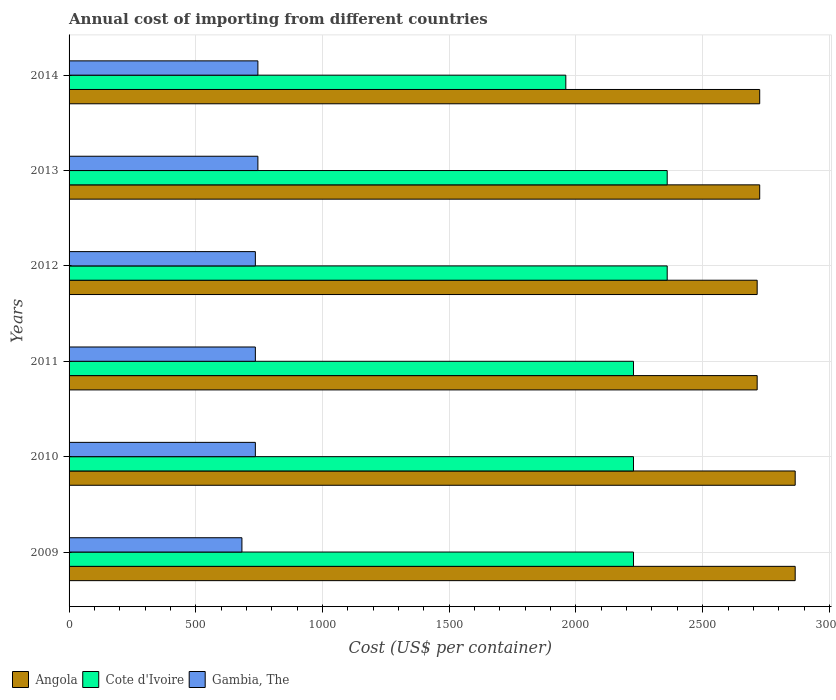How many groups of bars are there?
Offer a very short reply. 6. Are the number of bars on each tick of the Y-axis equal?
Keep it short and to the point. Yes. How many bars are there on the 1st tick from the top?
Your answer should be very brief. 3. How many bars are there on the 1st tick from the bottom?
Make the answer very short. 3. What is the label of the 3rd group of bars from the top?
Your response must be concise. 2012. In how many cases, is the number of bars for a given year not equal to the number of legend labels?
Provide a short and direct response. 0. What is the total annual cost of importing in Gambia, The in 2014?
Make the answer very short. 745. Across all years, what is the maximum total annual cost of importing in Gambia, The?
Keep it short and to the point. 745. Across all years, what is the minimum total annual cost of importing in Angola?
Your answer should be very brief. 2715. In which year was the total annual cost of importing in Cote d'Ivoire maximum?
Ensure brevity in your answer.  2012. What is the total total annual cost of importing in Gambia, The in the graph?
Ensure brevity in your answer.  4377. What is the difference between the total annual cost of importing in Gambia, The in 2012 and that in 2013?
Offer a very short reply. -10. What is the difference between the total annual cost of importing in Cote d'Ivoire in 2014 and the total annual cost of importing in Gambia, The in 2012?
Your response must be concise. 1225. What is the average total annual cost of importing in Angola per year?
Give a very brief answer. 2768.33. In the year 2009, what is the difference between the total annual cost of importing in Angola and total annual cost of importing in Gambia, The?
Ensure brevity in your answer.  2183. What is the ratio of the total annual cost of importing in Gambia, The in 2011 to that in 2014?
Provide a succinct answer. 0.99. Is the total annual cost of importing in Angola in 2012 less than that in 2013?
Make the answer very short. Yes. Is the difference between the total annual cost of importing in Angola in 2009 and 2010 greater than the difference between the total annual cost of importing in Gambia, The in 2009 and 2010?
Your answer should be very brief. Yes. What is the difference between the highest and the second highest total annual cost of importing in Angola?
Keep it short and to the point. 0. What is the difference between the highest and the lowest total annual cost of importing in Angola?
Make the answer very short. 150. In how many years, is the total annual cost of importing in Gambia, The greater than the average total annual cost of importing in Gambia, The taken over all years?
Ensure brevity in your answer.  5. What does the 3rd bar from the top in 2012 represents?
Give a very brief answer. Angola. What does the 1st bar from the bottom in 2010 represents?
Offer a very short reply. Angola. Is it the case that in every year, the sum of the total annual cost of importing in Gambia, The and total annual cost of importing in Cote d'Ivoire is greater than the total annual cost of importing in Angola?
Offer a terse response. No. Are all the bars in the graph horizontal?
Your response must be concise. Yes. What is the difference between two consecutive major ticks on the X-axis?
Make the answer very short. 500. Does the graph contain grids?
Your answer should be very brief. Yes. How many legend labels are there?
Provide a short and direct response. 3. What is the title of the graph?
Provide a succinct answer. Annual cost of importing from different countries. Does "Sweden" appear as one of the legend labels in the graph?
Keep it short and to the point. No. What is the label or title of the X-axis?
Offer a very short reply. Cost (US$ per container). What is the label or title of the Y-axis?
Give a very brief answer. Years. What is the Cost (US$ per container) of Angola in 2009?
Make the answer very short. 2865. What is the Cost (US$ per container) of Cote d'Ivoire in 2009?
Offer a terse response. 2227. What is the Cost (US$ per container) of Gambia, The in 2009?
Keep it short and to the point. 682. What is the Cost (US$ per container) of Angola in 2010?
Give a very brief answer. 2865. What is the Cost (US$ per container) of Cote d'Ivoire in 2010?
Offer a very short reply. 2227. What is the Cost (US$ per container) in Gambia, The in 2010?
Your response must be concise. 735. What is the Cost (US$ per container) of Angola in 2011?
Your answer should be compact. 2715. What is the Cost (US$ per container) in Cote d'Ivoire in 2011?
Provide a short and direct response. 2227. What is the Cost (US$ per container) in Gambia, The in 2011?
Make the answer very short. 735. What is the Cost (US$ per container) of Angola in 2012?
Your answer should be very brief. 2715. What is the Cost (US$ per container) of Cote d'Ivoire in 2012?
Your answer should be very brief. 2360. What is the Cost (US$ per container) in Gambia, The in 2012?
Your response must be concise. 735. What is the Cost (US$ per container) in Angola in 2013?
Provide a succinct answer. 2725. What is the Cost (US$ per container) of Cote d'Ivoire in 2013?
Offer a very short reply. 2360. What is the Cost (US$ per container) of Gambia, The in 2013?
Make the answer very short. 745. What is the Cost (US$ per container) in Angola in 2014?
Ensure brevity in your answer.  2725. What is the Cost (US$ per container) of Cote d'Ivoire in 2014?
Your response must be concise. 1960. What is the Cost (US$ per container) in Gambia, The in 2014?
Provide a short and direct response. 745. Across all years, what is the maximum Cost (US$ per container) in Angola?
Your response must be concise. 2865. Across all years, what is the maximum Cost (US$ per container) of Cote d'Ivoire?
Your answer should be compact. 2360. Across all years, what is the maximum Cost (US$ per container) in Gambia, The?
Give a very brief answer. 745. Across all years, what is the minimum Cost (US$ per container) in Angola?
Offer a terse response. 2715. Across all years, what is the minimum Cost (US$ per container) of Cote d'Ivoire?
Offer a very short reply. 1960. Across all years, what is the minimum Cost (US$ per container) in Gambia, The?
Offer a very short reply. 682. What is the total Cost (US$ per container) of Angola in the graph?
Provide a short and direct response. 1.66e+04. What is the total Cost (US$ per container) of Cote d'Ivoire in the graph?
Provide a short and direct response. 1.34e+04. What is the total Cost (US$ per container) of Gambia, The in the graph?
Your answer should be compact. 4377. What is the difference between the Cost (US$ per container) in Angola in 2009 and that in 2010?
Make the answer very short. 0. What is the difference between the Cost (US$ per container) in Gambia, The in 2009 and that in 2010?
Keep it short and to the point. -53. What is the difference between the Cost (US$ per container) in Angola in 2009 and that in 2011?
Offer a terse response. 150. What is the difference between the Cost (US$ per container) in Gambia, The in 2009 and that in 2011?
Provide a succinct answer. -53. What is the difference between the Cost (US$ per container) of Angola in 2009 and that in 2012?
Give a very brief answer. 150. What is the difference between the Cost (US$ per container) in Cote d'Ivoire in 2009 and that in 2012?
Your answer should be very brief. -133. What is the difference between the Cost (US$ per container) in Gambia, The in 2009 and that in 2012?
Offer a terse response. -53. What is the difference between the Cost (US$ per container) of Angola in 2009 and that in 2013?
Your answer should be very brief. 140. What is the difference between the Cost (US$ per container) in Cote d'Ivoire in 2009 and that in 2013?
Provide a short and direct response. -133. What is the difference between the Cost (US$ per container) of Gambia, The in 2009 and that in 2013?
Offer a terse response. -63. What is the difference between the Cost (US$ per container) in Angola in 2009 and that in 2014?
Provide a short and direct response. 140. What is the difference between the Cost (US$ per container) of Cote d'Ivoire in 2009 and that in 2014?
Offer a very short reply. 267. What is the difference between the Cost (US$ per container) of Gambia, The in 2009 and that in 2014?
Give a very brief answer. -63. What is the difference between the Cost (US$ per container) of Angola in 2010 and that in 2011?
Provide a short and direct response. 150. What is the difference between the Cost (US$ per container) in Cote d'Ivoire in 2010 and that in 2011?
Keep it short and to the point. 0. What is the difference between the Cost (US$ per container) of Gambia, The in 2010 and that in 2011?
Your response must be concise. 0. What is the difference between the Cost (US$ per container) of Angola in 2010 and that in 2012?
Your answer should be compact. 150. What is the difference between the Cost (US$ per container) of Cote d'Ivoire in 2010 and that in 2012?
Your answer should be compact. -133. What is the difference between the Cost (US$ per container) in Angola in 2010 and that in 2013?
Ensure brevity in your answer.  140. What is the difference between the Cost (US$ per container) in Cote d'Ivoire in 2010 and that in 2013?
Provide a short and direct response. -133. What is the difference between the Cost (US$ per container) of Gambia, The in 2010 and that in 2013?
Ensure brevity in your answer.  -10. What is the difference between the Cost (US$ per container) of Angola in 2010 and that in 2014?
Give a very brief answer. 140. What is the difference between the Cost (US$ per container) of Cote d'Ivoire in 2010 and that in 2014?
Make the answer very short. 267. What is the difference between the Cost (US$ per container) of Gambia, The in 2010 and that in 2014?
Keep it short and to the point. -10. What is the difference between the Cost (US$ per container) in Angola in 2011 and that in 2012?
Provide a short and direct response. 0. What is the difference between the Cost (US$ per container) in Cote d'Ivoire in 2011 and that in 2012?
Your answer should be compact. -133. What is the difference between the Cost (US$ per container) of Angola in 2011 and that in 2013?
Offer a terse response. -10. What is the difference between the Cost (US$ per container) in Cote d'Ivoire in 2011 and that in 2013?
Provide a short and direct response. -133. What is the difference between the Cost (US$ per container) in Cote d'Ivoire in 2011 and that in 2014?
Your answer should be compact. 267. What is the difference between the Cost (US$ per container) in Gambia, The in 2011 and that in 2014?
Give a very brief answer. -10. What is the difference between the Cost (US$ per container) of Angola in 2012 and that in 2013?
Your answer should be very brief. -10. What is the difference between the Cost (US$ per container) of Gambia, The in 2012 and that in 2013?
Your answer should be compact. -10. What is the difference between the Cost (US$ per container) in Cote d'Ivoire in 2012 and that in 2014?
Offer a very short reply. 400. What is the difference between the Cost (US$ per container) of Gambia, The in 2012 and that in 2014?
Offer a very short reply. -10. What is the difference between the Cost (US$ per container) in Angola in 2013 and that in 2014?
Provide a succinct answer. 0. What is the difference between the Cost (US$ per container) in Angola in 2009 and the Cost (US$ per container) in Cote d'Ivoire in 2010?
Ensure brevity in your answer.  638. What is the difference between the Cost (US$ per container) of Angola in 2009 and the Cost (US$ per container) of Gambia, The in 2010?
Keep it short and to the point. 2130. What is the difference between the Cost (US$ per container) in Cote d'Ivoire in 2009 and the Cost (US$ per container) in Gambia, The in 2010?
Give a very brief answer. 1492. What is the difference between the Cost (US$ per container) in Angola in 2009 and the Cost (US$ per container) in Cote d'Ivoire in 2011?
Provide a short and direct response. 638. What is the difference between the Cost (US$ per container) of Angola in 2009 and the Cost (US$ per container) of Gambia, The in 2011?
Keep it short and to the point. 2130. What is the difference between the Cost (US$ per container) in Cote d'Ivoire in 2009 and the Cost (US$ per container) in Gambia, The in 2011?
Offer a terse response. 1492. What is the difference between the Cost (US$ per container) of Angola in 2009 and the Cost (US$ per container) of Cote d'Ivoire in 2012?
Your answer should be very brief. 505. What is the difference between the Cost (US$ per container) in Angola in 2009 and the Cost (US$ per container) in Gambia, The in 2012?
Keep it short and to the point. 2130. What is the difference between the Cost (US$ per container) of Cote d'Ivoire in 2009 and the Cost (US$ per container) of Gambia, The in 2012?
Make the answer very short. 1492. What is the difference between the Cost (US$ per container) of Angola in 2009 and the Cost (US$ per container) of Cote d'Ivoire in 2013?
Make the answer very short. 505. What is the difference between the Cost (US$ per container) in Angola in 2009 and the Cost (US$ per container) in Gambia, The in 2013?
Ensure brevity in your answer.  2120. What is the difference between the Cost (US$ per container) in Cote d'Ivoire in 2009 and the Cost (US$ per container) in Gambia, The in 2013?
Your answer should be very brief. 1482. What is the difference between the Cost (US$ per container) in Angola in 2009 and the Cost (US$ per container) in Cote d'Ivoire in 2014?
Your answer should be very brief. 905. What is the difference between the Cost (US$ per container) in Angola in 2009 and the Cost (US$ per container) in Gambia, The in 2014?
Keep it short and to the point. 2120. What is the difference between the Cost (US$ per container) of Cote d'Ivoire in 2009 and the Cost (US$ per container) of Gambia, The in 2014?
Make the answer very short. 1482. What is the difference between the Cost (US$ per container) in Angola in 2010 and the Cost (US$ per container) in Cote d'Ivoire in 2011?
Your answer should be very brief. 638. What is the difference between the Cost (US$ per container) in Angola in 2010 and the Cost (US$ per container) in Gambia, The in 2011?
Offer a very short reply. 2130. What is the difference between the Cost (US$ per container) of Cote d'Ivoire in 2010 and the Cost (US$ per container) of Gambia, The in 2011?
Give a very brief answer. 1492. What is the difference between the Cost (US$ per container) in Angola in 2010 and the Cost (US$ per container) in Cote d'Ivoire in 2012?
Your response must be concise. 505. What is the difference between the Cost (US$ per container) of Angola in 2010 and the Cost (US$ per container) of Gambia, The in 2012?
Give a very brief answer. 2130. What is the difference between the Cost (US$ per container) of Cote d'Ivoire in 2010 and the Cost (US$ per container) of Gambia, The in 2012?
Give a very brief answer. 1492. What is the difference between the Cost (US$ per container) of Angola in 2010 and the Cost (US$ per container) of Cote d'Ivoire in 2013?
Your answer should be very brief. 505. What is the difference between the Cost (US$ per container) of Angola in 2010 and the Cost (US$ per container) of Gambia, The in 2013?
Make the answer very short. 2120. What is the difference between the Cost (US$ per container) in Cote d'Ivoire in 2010 and the Cost (US$ per container) in Gambia, The in 2013?
Your answer should be very brief. 1482. What is the difference between the Cost (US$ per container) in Angola in 2010 and the Cost (US$ per container) in Cote d'Ivoire in 2014?
Offer a very short reply. 905. What is the difference between the Cost (US$ per container) in Angola in 2010 and the Cost (US$ per container) in Gambia, The in 2014?
Give a very brief answer. 2120. What is the difference between the Cost (US$ per container) in Cote d'Ivoire in 2010 and the Cost (US$ per container) in Gambia, The in 2014?
Your answer should be very brief. 1482. What is the difference between the Cost (US$ per container) of Angola in 2011 and the Cost (US$ per container) of Cote d'Ivoire in 2012?
Give a very brief answer. 355. What is the difference between the Cost (US$ per container) in Angola in 2011 and the Cost (US$ per container) in Gambia, The in 2012?
Your answer should be very brief. 1980. What is the difference between the Cost (US$ per container) in Cote d'Ivoire in 2011 and the Cost (US$ per container) in Gambia, The in 2012?
Ensure brevity in your answer.  1492. What is the difference between the Cost (US$ per container) of Angola in 2011 and the Cost (US$ per container) of Cote d'Ivoire in 2013?
Offer a terse response. 355. What is the difference between the Cost (US$ per container) of Angola in 2011 and the Cost (US$ per container) of Gambia, The in 2013?
Give a very brief answer. 1970. What is the difference between the Cost (US$ per container) of Cote d'Ivoire in 2011 and the Cost (US$ per container) of Gambia, The in 2013?
Provide a short and direct response. 1482. What is the difference between the Cost (US$ per container) in Angola in 2011 and the Cost (US$ per container) in Cote d'Ivoire in 2014?
Offer a very short reply. 755. What is the difference between the Cost (US$ per container) in Angola in 2011 and the Cost (US$ per container) in Gambia, The in 2014?
Make the answer very short. 1970. What is the difference between the Cost (US$ per container) in Cote d'Ivoire in 2011 and the Cost (US$ per container) in Gambia, The in 2014?
Offer a terse response. 1482. What is the difference between the Cost (US$ per container) in Angola in 2012 and the Cost (US$ per container) in Cote d'Ivoire in 2013?
Ensure brevity in your answer.  355. What is the difference between the Cost (US$ per container) of Angola in 2012 and the Cost (US$ per container) of Gambia, The in 2013?
Provide a succinct answer. 1970. What is the difference between the Cost (US$ per container) in Cote d'Ivoire in 2012 and the Cost (US$ per container) in Gambia, The in 2013?
Offer a very short reply. 1615. What is the difference between the Cost (US$ per container) in Angola in 2012 and the Cost (US$ per container) in Cote d'Ivoire in 2014?
Ensure brevity in your answer.  755. What is the difference between the Cost (US$ per container) in Angola in 2012 and the Cost (US$ per container) in Gambia, The in 2014?
Your answer should be very brief. 1970. What is the difference between the Cost (US$ per container) of Cote d'Ivoire in 2012 and the Cost (US$ per container) of Gambia, The in 2014?
Offer a terse response. 1615. What is the difference between the Cost (US$ per container) of Angola in 2013 and the Cost (US$ per container) of Cote d'Ivoire in 2014?
Offer a very short reply. 765. What is the difference between the Cost (US$ per container) in Angola in 2013 and the Cost (US$ per container) in Gambia, The in 2014?
Give a very brief answer. 1980. What is the difference between the Cost (US$ per container) of Cote d'Ivoire in 2013 and the Cost (US$ per container) of Gambia, The in 2014?
Keep it short and to the point. 1615. What is the average Cost (US$ per container) in Angola per year?
Offer a very short reply. 2768.33. What is the average Cost (US$ per container) of Cote d'Ivoire per year?
Keep it short and to the point. 2226.83. What is the average Cost (US$ per container) in Gambia, The per year?
Offer a terse response. 729.5. In the year 2009, what is the difference between the Cost (US$ per container) of Angola and Cost (US$ per container) of Cote d'Ivoire?
Make the answer very short. 638. In the year 2009, what is the difference between the Cost (US$ per container) of Angola and Cost (US$ per container) of Gambia, The?
Your answer should be very brief. 2183. In the year 2009, what is the difference between the Cost (US$ per container) of Cote d'Ivoire and Cost (US$ per container) of Gambia, The?
Your answer should be very brief. 1545. In the year 2010, what is the difference between the Cost (US$ per container) of Angola and Cost (US$ per container) of Cote d'Ivoire?
Make the answer very short. 638. In the year 2010, what is the difference between the Cost (US$ per container) in Angola and Cost (US$ per container) in Gambia, The?
Ensure brevity in your answer.  2130. In the year 2010, what is the difference between the Cost (US$ per container) in Cote d'Ivoire and Cost (US$ per container) in Gambia, The?
Provide a short and direct response. 1492. In the year 2011, what is the difference between the Cost (US$ per container) in Angola and Cost (US$ per container) in Cote d'Ivoire?
Provide a short and direct response. 488. In the year 2011, what is the difference between the Cost (US$ per container) in Angola and Cost (US$ per container) in Gambia, The?
Your response must be concise. 1980. In the year 2011, what is the difference between the Cost (US$ per container) in Cote d'Ivoire and Cost (US$ per container) in Gambia, The?
Provide a succinct answer. 1492. In the year 2012, what is the difference between the Cost (US$ per container) of Angola and Cost (US$ per container) of Cote d'Ivoire?
Provide a short and direct response. 355. In the year 2012, what is the difference between the Cost (US$ per container) of Angola and Cost (US$ per container) of Gambia, The?
Provide a succinct answer. 1980. In the year 2012, what is the difference between the Cost (US$ per container) in Cote d'Ivoire and Cost (US$ per container) in Gambia, The?
Make the answer very short. 1625. In the year 2013, what is the difference between the Cost (US$ per container) of Angola and Cost (US$ per container) of Cote d'Ivoire?
Make the answer very short. 365. In the year 2013, what is the difference between the Cost (US$ per container) of Angola and Cost (US$ per container) of Gambia, The?
Provide a succinct answer. 1980. In the year 2013, what is the difference between the Cost (US$ per container) of Cote d'Ivoire and Cost (US$ per container) of Gambia, The?
Your answer should be very brief. 1615. In the year 2014, what is the difference between the Cost (US$ per container) in Angola and Cost (US$ per container) in Cote d'Ivoire?
Offer a very short reply. 765. In the year 2014, what is the difference between the Cost (US$ per container) in Angola and Cost (US$ per container) in Gambia, The?
Your response must be concise. 1980. In the year 2014, what is the difference between the Cost (US$ per container) in Cote d'Ivoire and Cost (US$ per container) in Gambia, The?
Offer a terse response. 1215. What is the ratio of the Cost (US$ per container) in Gambia, The in 2009 to that in 2010?
Your answer should be very brief. 0.93. What is the ratio of the Cost (US$ per container) in Angola in 2009 to that in 2011?
Give a very brief answer. 1.06. What is the ratio of the Cost (US$ per container) of Cote d'Ivoire in 2009 to that in 2011?
Make the answer very short. 1. What is the ratio of the Cost (US$ per container) of Gambia, The in 2009 to that in 2011?
Provide a succinct answer. 0.93. What is the ratio of the Cost (US$ per container) of Angola in 2009 to that in 2012?
Your response must be concise. 1.06. What is the ratio of the Cost (US$ per container) of Cote d'Ivoire in 2009 to that in 2012?
Your answer should be compact. 0.94. What is the ratio of the Cost (US$ per container) of Gambia, The in 2009 to that in 2012?
Give a very brief answer. 0.93. What is the ratio of the Cost (US$ per container) of Angola in 2009 to that in 2013?
Offer a terse response. 1.05. What is the ratio of the Cost (US$ per container) of Cote d'Ivoire in 2009 to that in 2013?
Give a very brief answer. 0.94. What is the ratio of the Cost (US$ per container) of Gambia, The in 2009 to that in 2013?
Your response must be concise. 0.92. What is the ratio of the Cost (US$ per container) of Angola in 2009 to that in 2014?
Make the answer very short. 1.05. What is the ratio of the Cost (US$ per container) of Cote d'Ivoire in 2009 to that in 2014?
Make the answer very short. 1.14. What is the ratio of the Cost (US$ per container) of Gambia, The in 2009 to that in 2014?
Provide a short and direct response. 0.92. What is the ratio of the Cost (US$ per container) of Angola in 2010 to that in 2011?
Provide a succinct answer. 1.06. What is the ratio of the Cost (US$ per container) of Angola in 2010 to that in 2012?
Provide a short and direct response. 1.06. What is the ratio of the Cost (US$ per container) of Cote d'Ivoire in 2010 to that in 2012?
Ensure brevity in your answer.  0.94. What is the ratio of the Cost (US$ per container) of Angola in 2010 to that in 2013?
Your answer should be compact. 1.05. What is the ratio of the Cost (US$ per container) in Cote d'Ivoire in 2010 to that in 2013?
Provide a succinct answer. 0.94. What is the ratio of the Cost (US$ per container) in Gambia, The in 2010 to that in 2013?
Provide a short and direct response. 0.99. What is the ratio of the Cost (US$ per container) of Angola in 2010 to that in 2014?
Ensure brevity in your answer.  1.05. What is the ratio of the Cost (US$ per container) in Cote d'Ivoire in 2010 to that in 2014?
Make the answer very short. 1.14. What is the ratio of the Cost (US$ per container) of Gambia, The in 2010 to that in 2014?
Provide a short and direct response. 0.99. What is the ratio of the Cost (US$ per container) of Angola in 2011 to that in 2012?
Keep it short and to the point. 1. What is the ratio of the Cost (US$ per container) in Cote d'Ivoire in 2011 to that in 2012?
Make the answer very short. 0.94. What is the ratio of the Cost (US$ per container) of Gambia, The in 2011 to that in 2012?
Provide a short and direct response. 1. What is the ratio of the Cost (US$ per container) of Cote d'Ivoire in 2011 to that in 2013?
Your answer should be very brief. 0.94. What is the ratio of the Cost (US$ per container) in Gambia, The in 2011 to that in 2013?
Offer a terse response. 0.99. What is the ratio of the Cost (US$ per container) in Cote d'Ivoire in 2011 to that in 2014?
Give a very brief answer. 1.14. What is the ratio of the Cost (US$ per container) of Gambia, The in 2011 to that in 2014?
Offer a terse response. 0.99. What is the ratio of the Cost (US$ per container) in Gambia, The in 2012 to that in 2013?
Ensure brevity in your answer.  0.99. What is the ratio of the Cost (US$ per container) of Angola in 2012 to that in 2014?
Your response must be concise. 1. What is the ratio of the Cost (US$ per container) in Cote d'Ivoire in 2012 to that in 2014?
Offer a terse response. 1.2. What is the ratio of the Cost (US$ per container) in Gambia, The in 2012 to that in 2014?
Keep it short and to the point. 0.99. What is the ratio of the Cost (US$ per container) of Angola in 2013 to that in 2014?
Your response must be concise. 1. What is the ratio of the Cost (US$ per container) in Cote d'Ivoire in 2013 to that in 2014?
Your response must be concise. 1.2. What is the difference between the highest and the lowest Cost (US$ per container) of Angola?
Ensure brevity in your answer.  150. What is the difference between the highest and the lowest Cost (US$ per container) in Cote d'Ivoire?
Give a very brief answer. 400. What is the difference between the highest and the lowest Cost (US$ per container) of Gambia, The?
Your response must be concise. 63. 